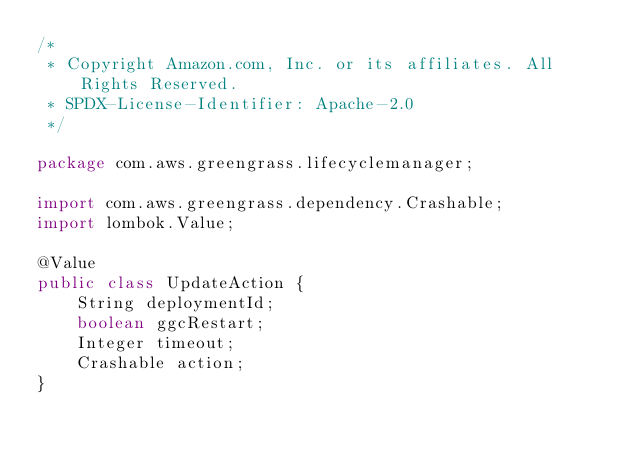<code> <loc_0><loc_0><loc_500><loc_500><_Java_>/*
 * Copyright Amazon.com, Inc. or its affiliates. All Rights Reserved.
 * SPDX-License-Identifier: Apache-2.0
 */

package com.aws.greengrass.lifecyclemanager;

import com.aws.greengrass.dependency.Crashable;
import lombok.Value;

@Value
public class UpdateAction {
    String deploymentId;
    boolean ggcRestart;
    Integer timeout;
    Crashable action;
}
</code> 